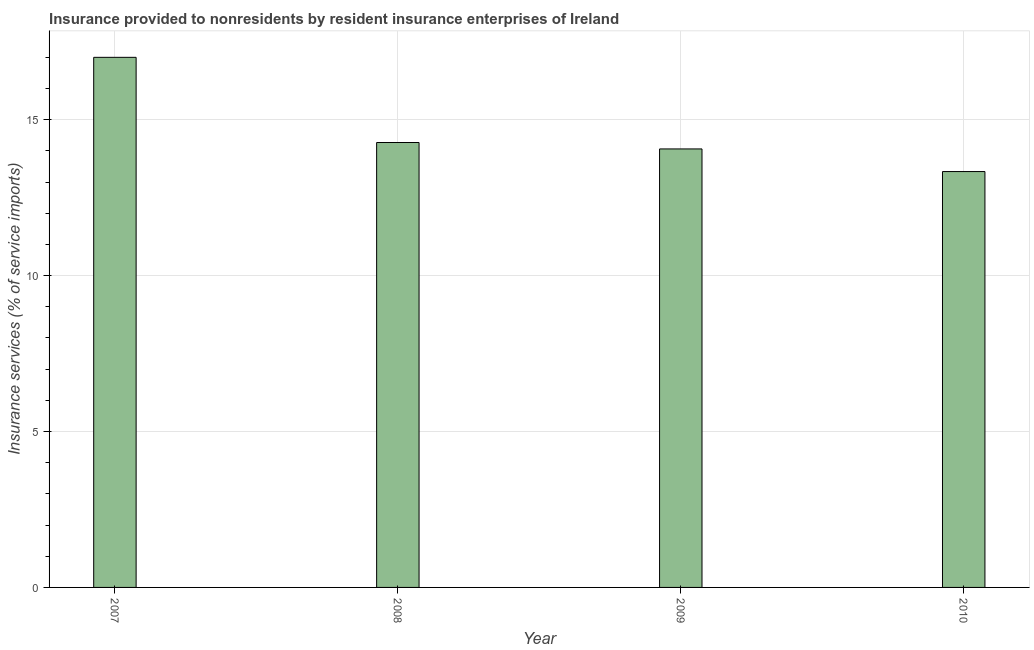What is the title of the graph?
Ensure brevity in your answer.  Insurance provided to nonresidents by resident insurance enterprises of Ireland. What is the label or title of the Y-axis?
Your response must be concise. Insurance services (% of service imports). What is the insurance and financial services in 2009?
Provide a short and direct response. 14.06. Across all years, what is the maximum insurance and financial services?
Provide a short and direct response. 17. Across all years, what is the minimum insurance and financial services?
Your answer should be compact. 13.34. In which year was the insurance and financial services maximum?
Offer a very short reply. 2007. What is the sum of the insurance and financial services?
Offer a terse response. 58.67. What is the difference between the insurance and financial services in 2009 and 2010?
Your answer should be compact. 0.73. What is the average insurance and financial services per year?
Offer a terse response. 14.67. What is the median insurance and financial services?
Your answer should be compact. 14.17. In how many years, is the insurance and financial services greater than 13 %?
Your response must be concise. 4. Do a majority of the years between 2008 and 2009 (inclusive) have insurance and financial services greater than 5 %?
Your answer should be compact. Yes. What is the ratio of the insurance and financial services in 2009 to that in 2010?
Provide a short and direct response. 1.05. What is the difference between the highest and the second highest insurance and financial services?
Offer a very short reply. 2.73. Is the sum of the insurance and financial services in 2007 and 2008 greater than the maximum insurance and financial services across all years?
Offer a terse response. Yes. What is the difference between the highest and the lowest insurance and financial services?
Provide a short and direct response. 3.66. Are all the bars in the graph horizontal?
Offer a very short reply. No. How many years are there in the graph?
Provide a succinct answer. 4. What is the difference between two consecutive major ticks on the Y-axis?
Give a very brief answer. 5. What is the Insurance services (% of service imports) in 2007?
Your answer should be very brief. 17. What is the Insurance services (% of service imports) of 2008?
Your answer should be compact. 14.27. What is the Insurance services (% of service imports) of 2009?
Provide a succinct answer. 14.06. What is the Insurance services (% of service imports) in 2010?
Keep it short and to the point. 13.34. What is the difference between the Insurance services (% of service imports) in 2007 and 2008?
Your answer should be very brief. 2.73. What is the difference between the Insurance services (% of service imports) in 2007 and 2009?
Provide a succinct answer. 2.94. What is the difference between the Insurance services (% of service imports) in 2007 and 2010?
Provide a short and direct response. 3.66. What is the difference between the Insurance services (% of service imports) in 2008 and 2009?
Your answer should be compact. 0.21. What is the difference between the Insurance services (% of service imports) in 2008 and 2010?
Make the answer very short. 0.93. What is the difference between the Insurance services (% of service imports) in 2009 and 2010?
Ensure brevity in your answer.  0.73. What is the ratio of the Insurance services (% of service imports) in 2007 to that in 2008?
Ensure brevity in your answer.  1.19. What is the ratio of the Insurance services (% of service imports) in 2007 to that in 2009?
Provide a short and direct response. 1.21. What is the ratio of the Insurance services (% of service imports) in 2007 to that in 2010?
Ensure brevity in your answer.  1.27. What is the ratio of the Insurance services (% of service imports) in 2008 to that in 2009?
Provide a succinct answer. 1.01. What is the ratio of the Insurance services (% of service imports) in 2008 to that in 2010?
Give a very brief answer. 1.07. What is the ratio of the Insurance services (% of service imports) in 2009 to that in 2010?
Your answer should be compact. 1.05. 